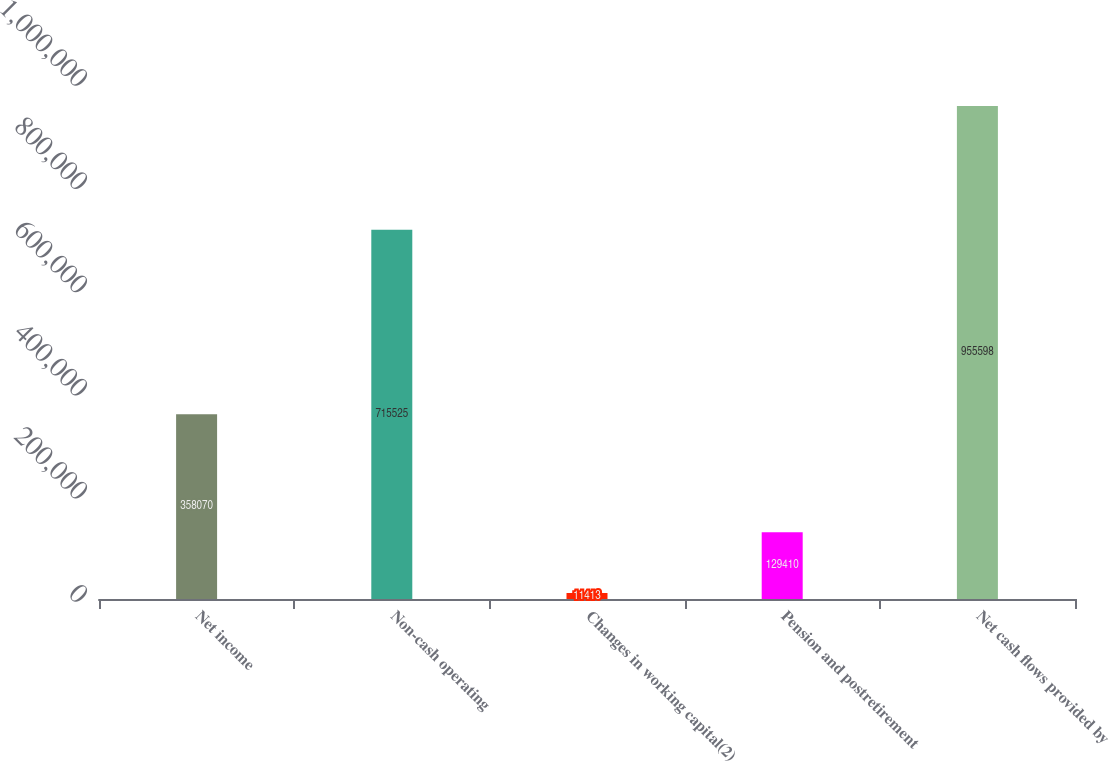Convert chart. <chart><loc_0><loc_0><loc_500><loc_500><bar_chart><fcel>Net income<fcel>Non-cash operating<fcel>Changes in working capital(2)<fcel>Pension and postretirement<fcel>Net cash flows provided by<nl><fcel>358070<fcel>715525<fcel>11413<fcel>129410<fcel>955598<nl></chart> 